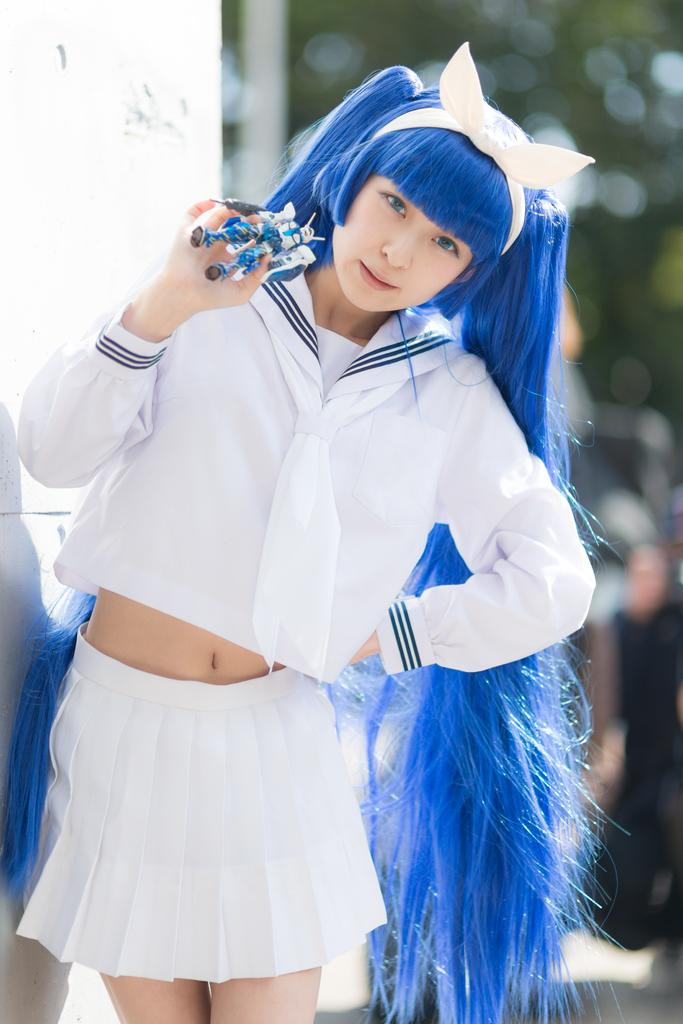What is the woman in the image doing? The woman is standing in the image and holding a toy. Can you describe the surroundings of the woman? There is a wall visible in the image, and the background is blurry. What type of flowers can be seen growing on the club in the image? There is no club or flowers present in the image. 